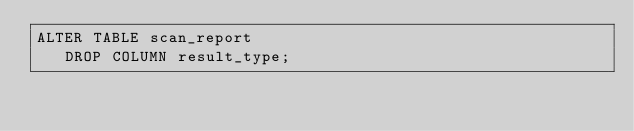Convert code to text. <code><loc_0><loc_0><loc_500><loc_500><_SQL_>ALTER TABLE scan_report 
   DROP COLUMN result_type;
</code> 